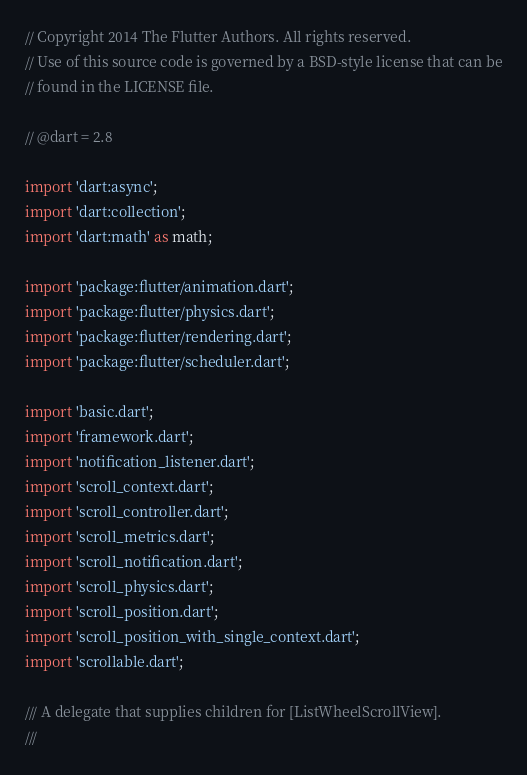Convert code to text. <code><loc_0><loc_0><loc_500><loc_500><_Dart_>// Copyright 2014 The Flutter Authors. All rights reserved.
// Use of this source code is governed by a BSD-style license that can be
// found in the LICENSE file.

// @dart = 2.8

import 'dart:async';
import 'dart:collection';
import 'dart:math' as math;

import 'package:flutter/animation.dart';
import 'package:flutter/physics.dart';
import 'package:flutter/rendering.dart';
import 'package:flutter/scheduler.dart';

import 'basic.dart';
import 'framework.dart';
import 'notification_listener.dart';
import 'scroll_context.dart';
import 'scroll_controller.dart';
import 'scroll_metrics.dart';
import 'scroll_notification.dart';
import 'scroll_physics.dart';
import 'scroll_position.dart';
import 'scroll_position_with_single_context.dart';
import 'scrollable.dart';

/// A delegate that supplies children for [ListWheelScrollView].
///</code> 